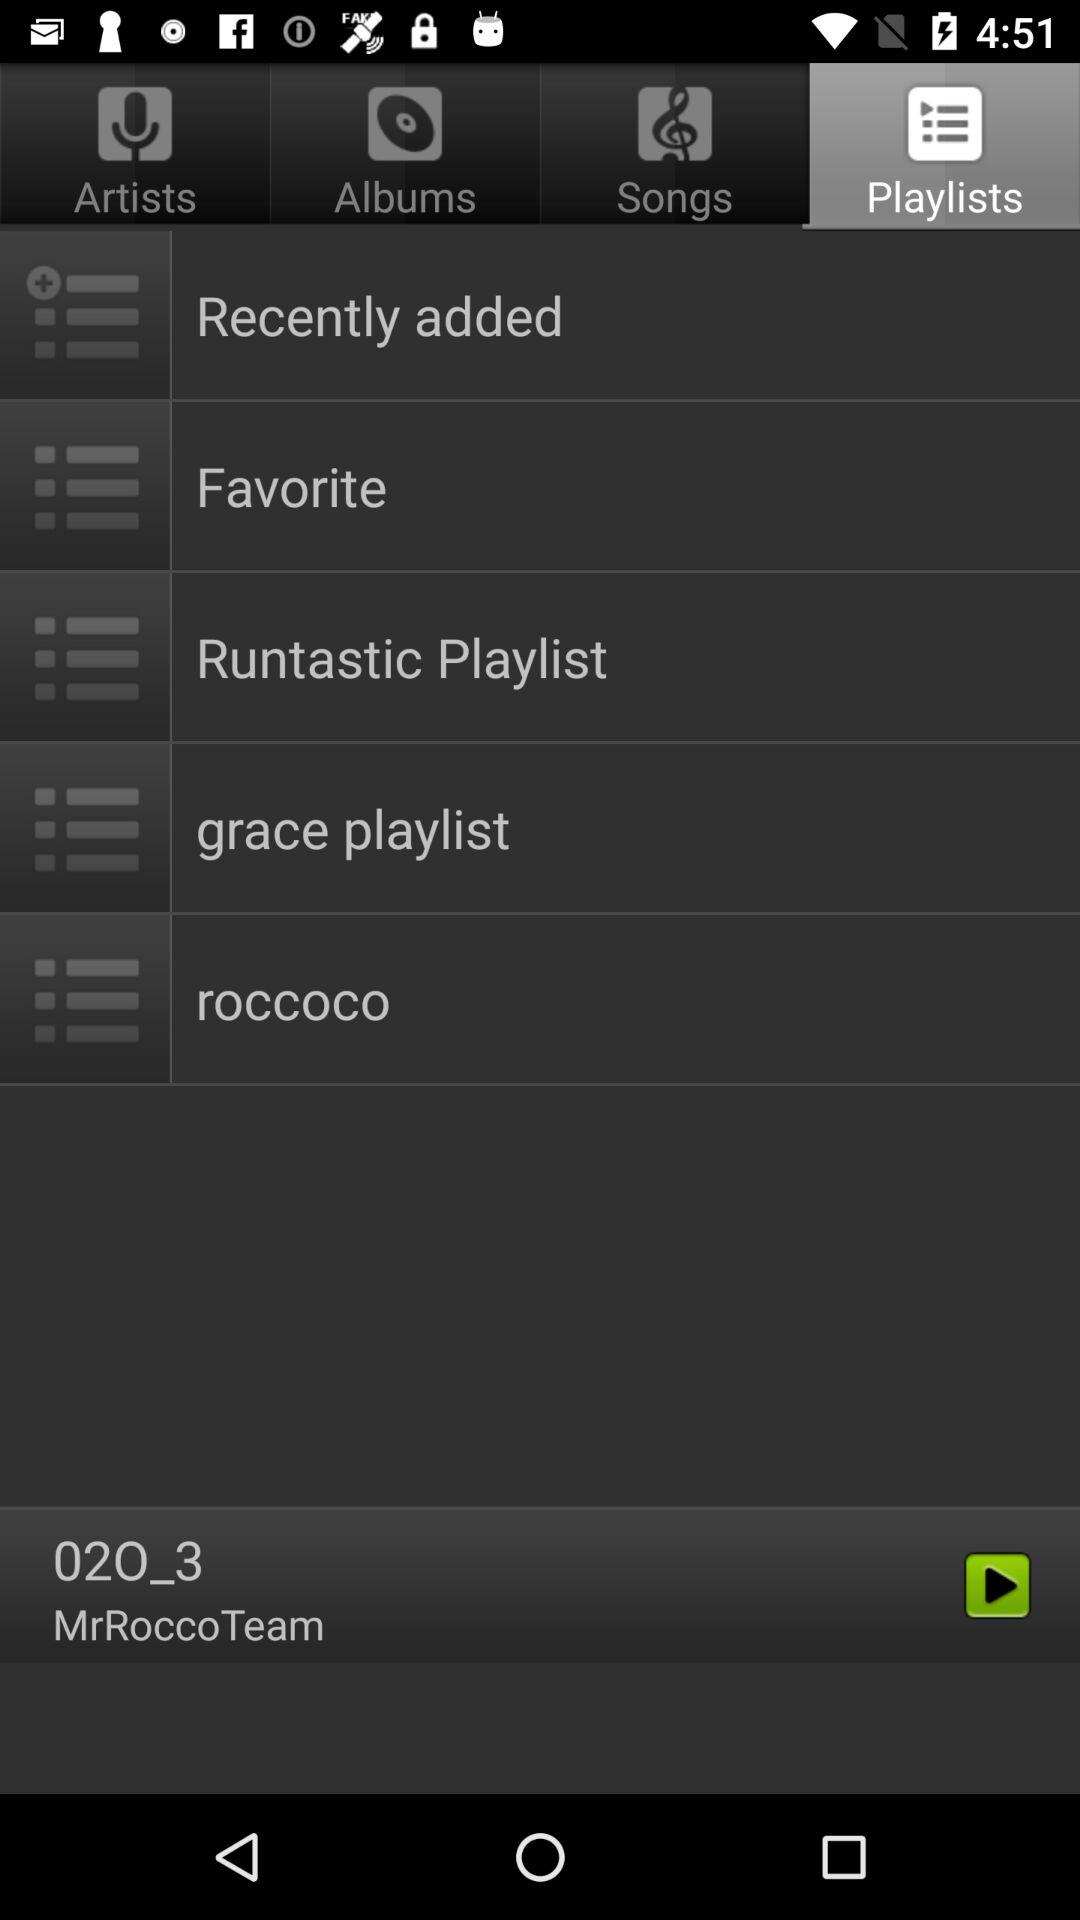Which audio is currently playing? The audio which is currently playing is 020_3. 